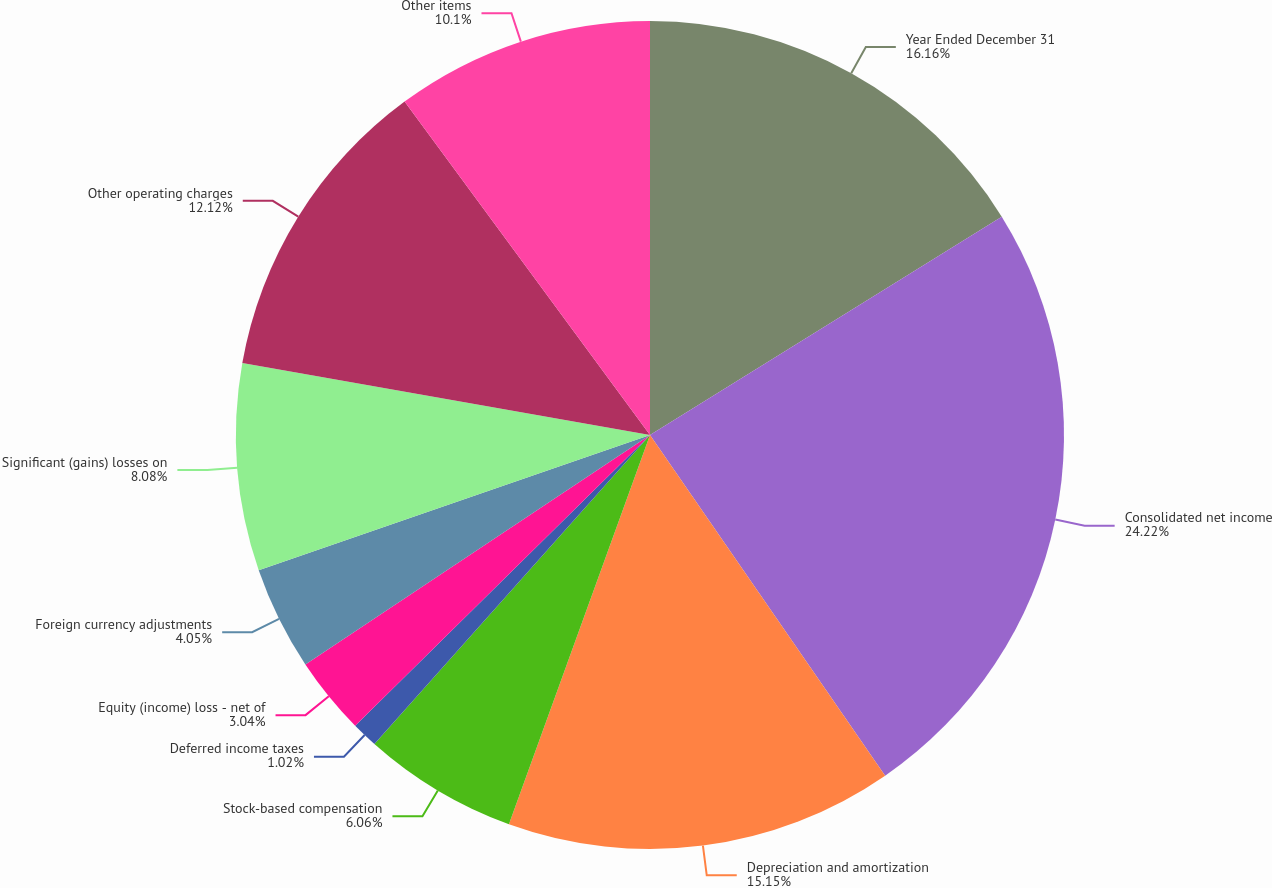Convert chart to OTSL. <chart><loc_0><loc_0><loc_500><loc_500><pie_chart><fcel>Year Ended December 31<fcel>Consolidated net income<fcel>Depreciation and amortization<fcel>Stock-based compensation<fcel>Deferred income taxes<fcel>Equity (income) loss - net of<fcel>Foreign currency adjustments<fcel>Significant (gains) losses on<fcel>Other operating charges<fcel>Other items<nl><fcel>16.16%<fcel>24.23%<fcel>15.15%<fcel>6.06%<fcel>1.02%<fcel>3.04%<fcel>4.05%<fcel>8.08%<fcel>12.12%<fcel>10.1%<nl></chart> 